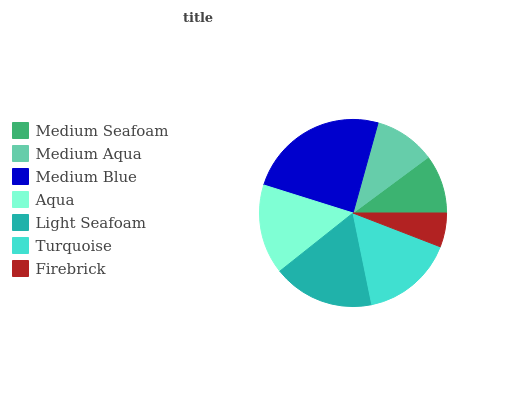Is Firebrick the minimum?
Answer yes or no. Yes. Is Medium Blue the maximum?
Answer yes or no. Yes. Is Medium Aqua the minimum?
Answer yes or no. No. Is Medium Aqua the maximum?
Answer yes or no. No. Is Medium Aqua greater than Medium Seafoam?
Answer yes or no. Yes. Is Medium Seafoam less than Medium Aqua?
Answer yes or no. Yes. Is Medium Seafoam greater than Medium Aqua?
Answer yes or no. No. Is Medium Aqua less than Medium Seafoam?
Answer yes or no. No. Is Aqua the high median?
Answer yes or no. Yes. Is Aqua the low median?
Answer yes or no. Yes. Is Medium Aqua the high median?
Answer yes or no. No. Is Light Seafoam the low median?
Answer yes or no. No. 